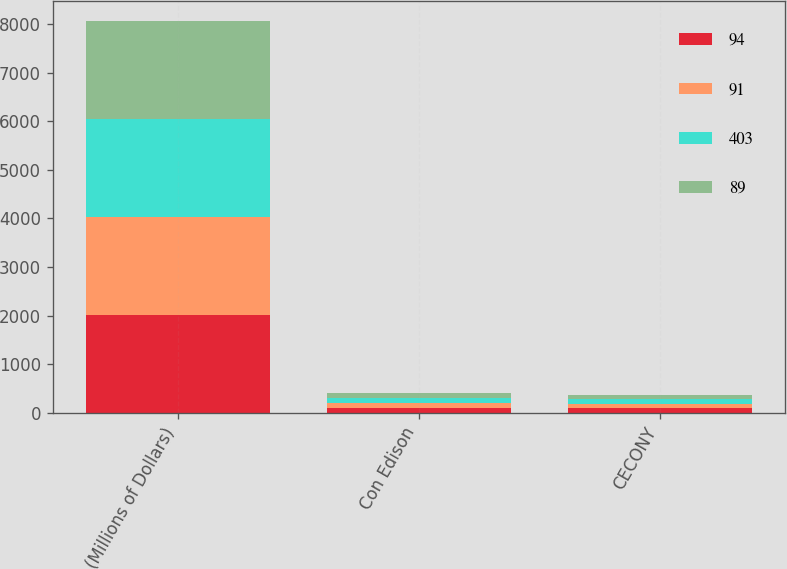Convert chart. <chart><loc_0><loc_0><loc_500><loc_500><stacked_bar_chart><ecel><fcel>(Millions of Dollars)<fcel>Con Edison<fcel>CECONY<nl><fcel>94<fcel>2014<fcel>105<fcel>94<nl><fcel>91<fcel>2016<fcel>102<fcel>91<nl><fcel>403<fcel>2017<fcel>101<fcel>89<nl><fcel>89<fcel>2018<fcel>99<fcel>88<nl></chart> 